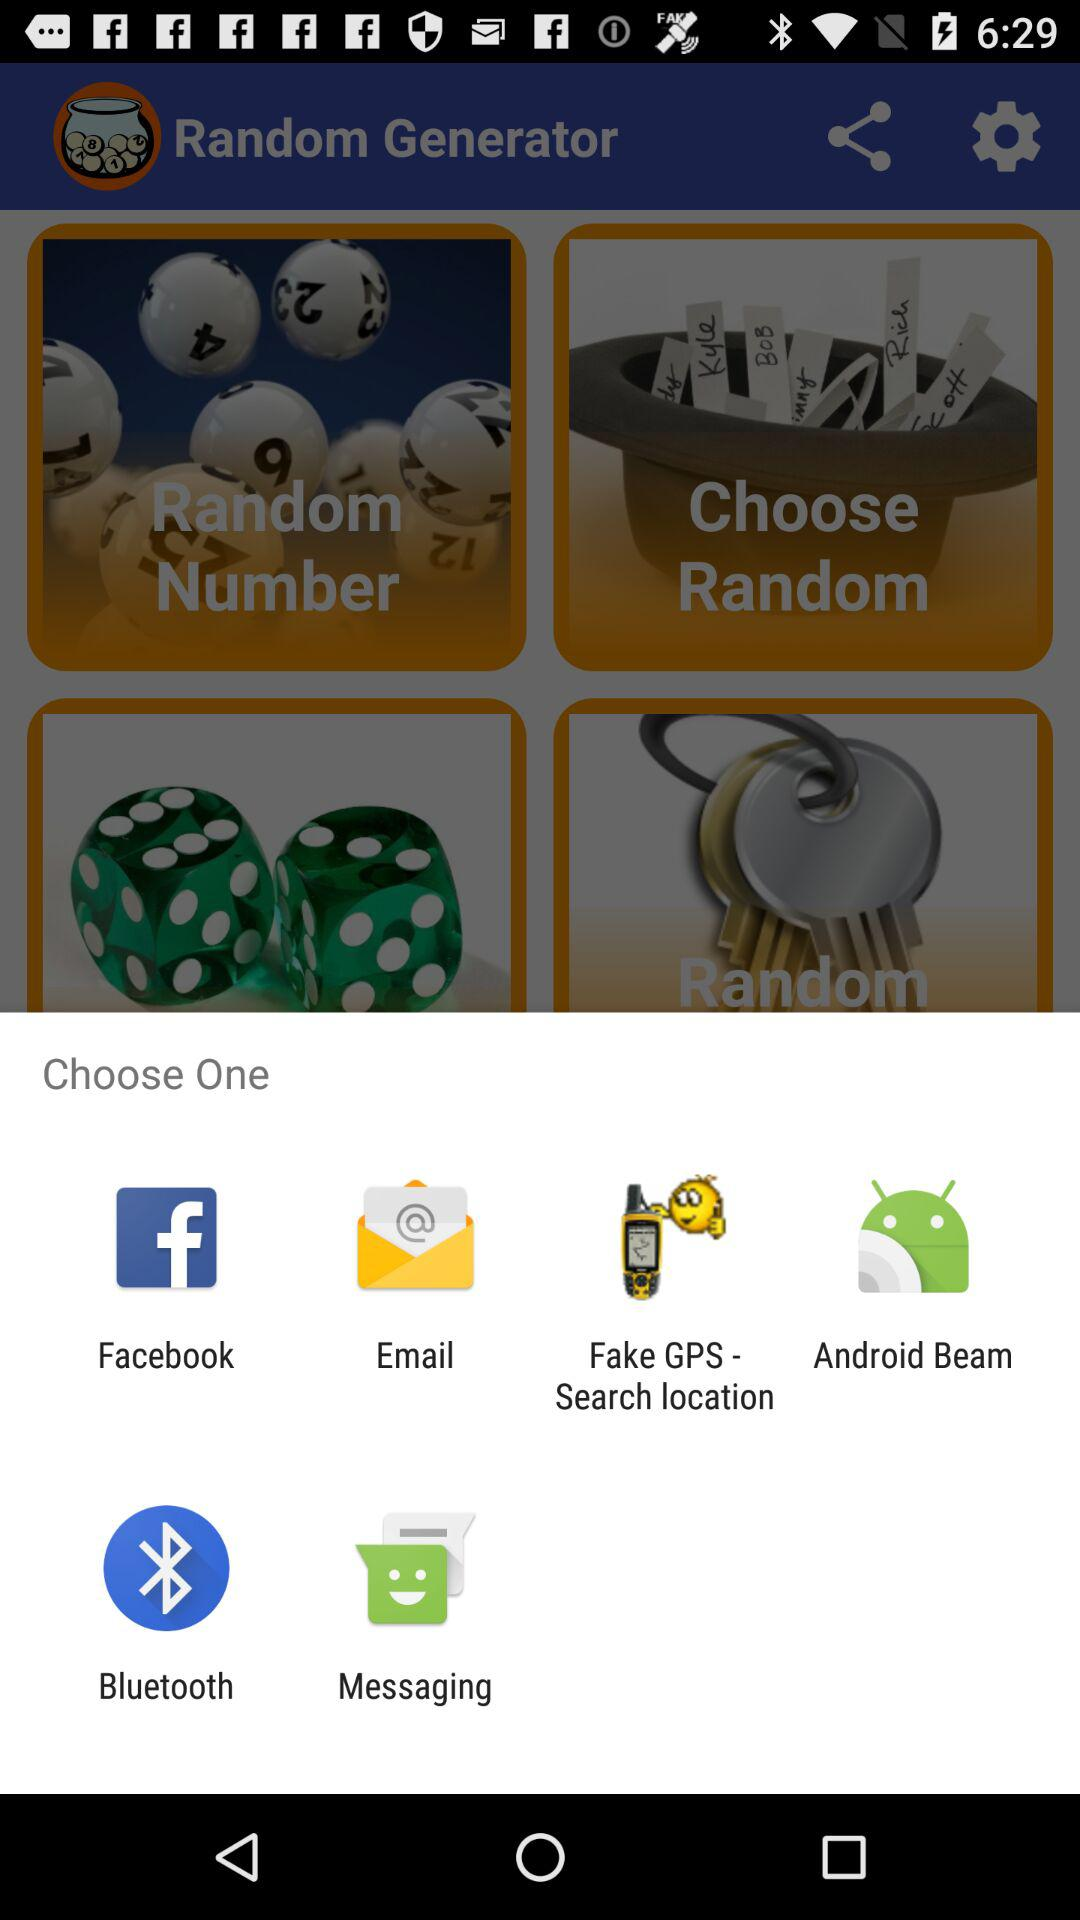What are the options to choose from? The options are "Facebook", "Email", "Fake GPS - Search location", "Android Beam", "Bluetooth" and "Messaging". 